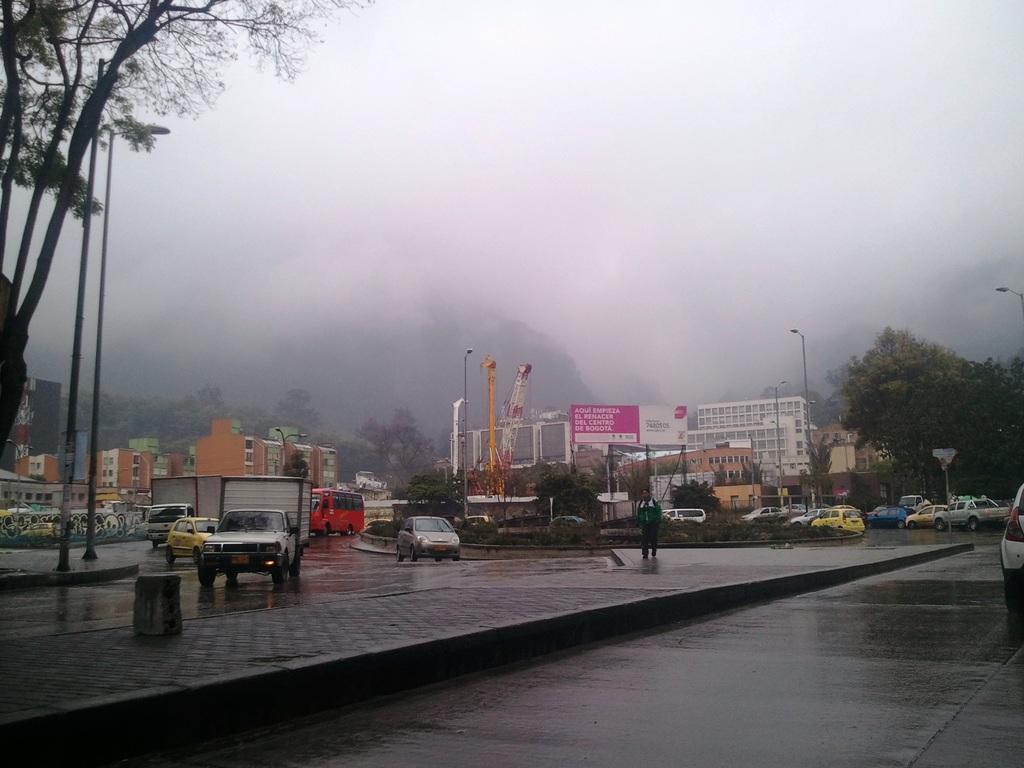What types of objects can be seen in the image? There are vehicles, poles, plants, trees, roads, a hoarding, buildings, and a person visible in the image. What is the purpose of the poles in the image? The poles in the image are likely used for supporting wires or signs. Can you describe the vegetation in the image? The image contains plants and trees. What type of infrastructure is present in the image? The image features roads and buildings. What is the background of the image? The sky is visible in the background of the image. What type of sail can be seen in the image? There is no sail present in the image. 